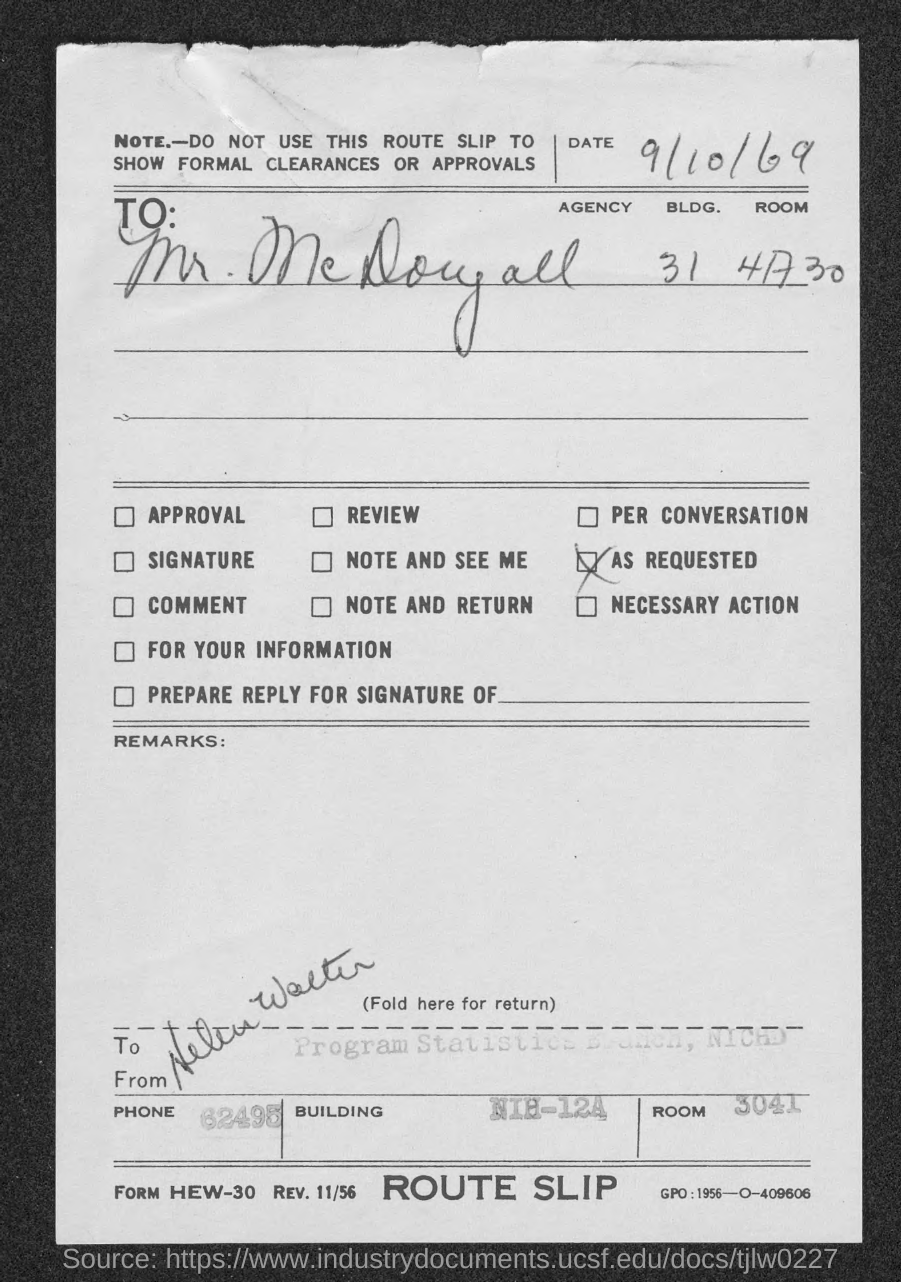Give some essential details in this illustration. The letter is addressed to Mr. McDougall. The Room Number is 3041. What is the phone number 62495...? What is the date? The date is September 10, 1969. 